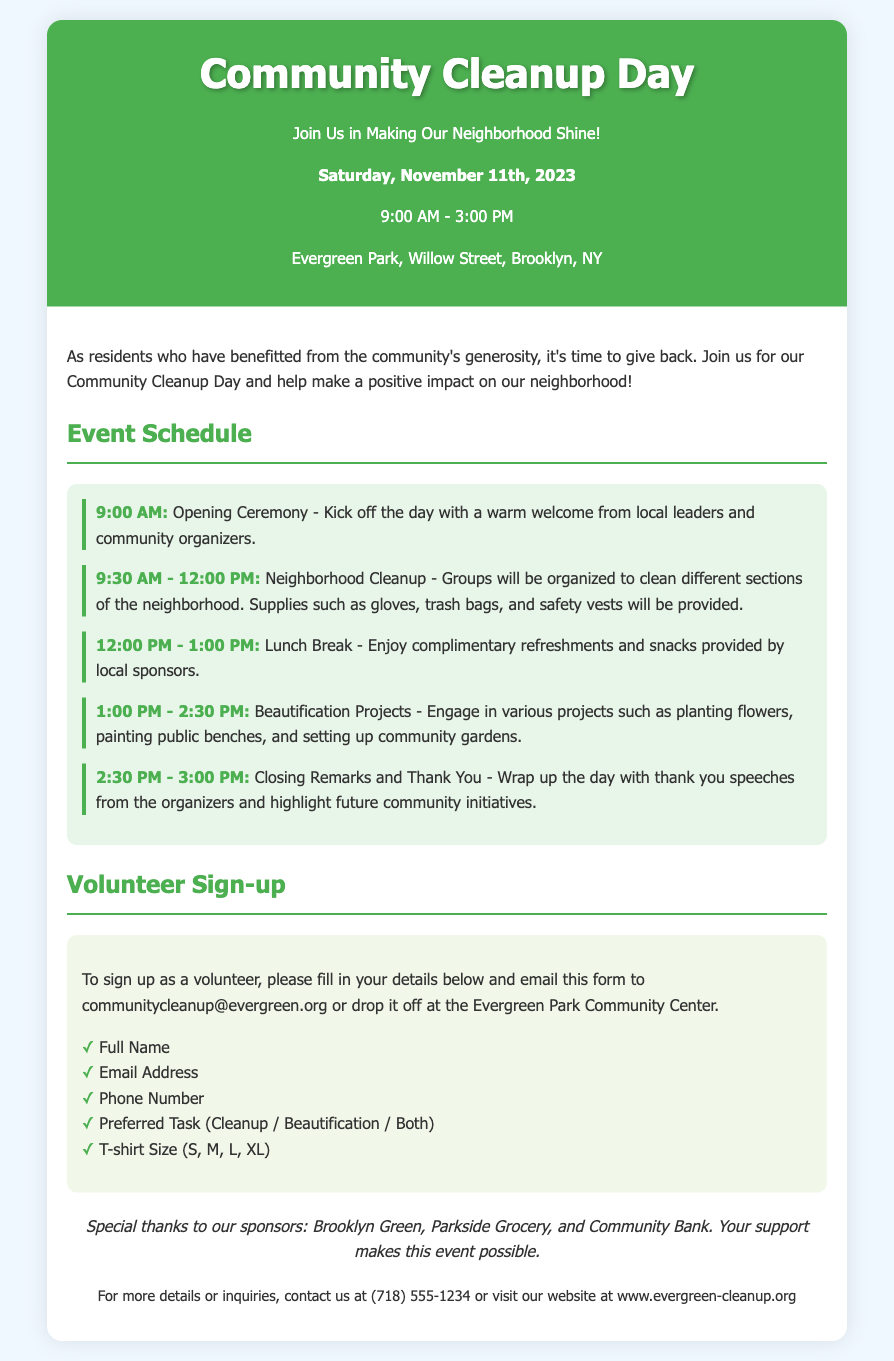What date is the Community Cleanup Day? The date for the event is specified in the document.
Answer: November 11th, 2023 What time does the Cleanup Day start? The starting time is mentioned early in the document.
Answer: 9:00 AM What is provided during the lunch break? The document details what participants can expect during the lunch break.
Answer: Complimentary refreshments and snacks What main activities occur from 1:00 PM to 2:30 PM? This spans the event schedule and indicates a specific activity block.
Answer: Beautification Projects Where should volunteers email their sign-up form? This is indicated in the section regarding the volunteer sign-up.
Answer: communitycleanup@evergreen.org What is the location of the event? The document specifies the venue for the cleanup day.
Answer: Evergreen Park, Willow Street, Brooklyn, NY What community action is emphasized in the introduction? This requires understanding the intent expressed in the introduction of the document.
Answer: Giving back Name one of the sponsors of the event. Acknowledgments section lists sponsors supporting the event.
Answer: Brooklyn Green 